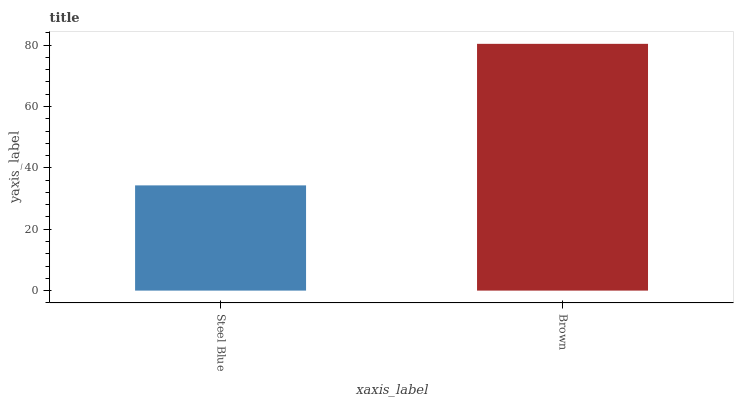Is Brown the minimum?
Answer yes or no. No. Is Brown greater than Steel Blue?
Answer yes or no. Yes. Is Steel Blue less than Brown?
Answer yes or no. Yes. Is Steel Blue greater than Brown?
Answer yes or no. No. Is Brown less than Steel Blue?
Answer yes or no. No. Is Brown the high median?
Answer yes or no. Yes. Is Steel Blue the low median?
Answer yes or no. Yes. Is Steel Blue the high median?
Answer yes or no. No. Is Brown the low median?
Answer yes or no. No. 